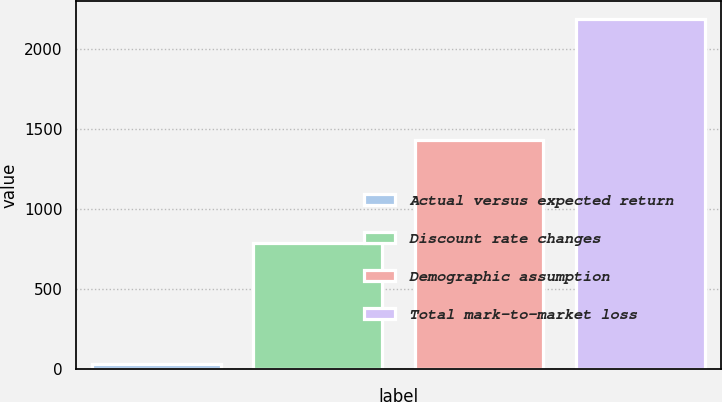Convert chart. <chart><loc_0><loc_0><loc_500><loc_500><bar_chart><fcel>Actual versus expected return<fcel>Discount rate changes<fcel>Demographic assumption<fcel>Total mark-to-market loss<nl><fcel>35<fcel>791<fcel>1434<fcel>2190<nl></chart> 